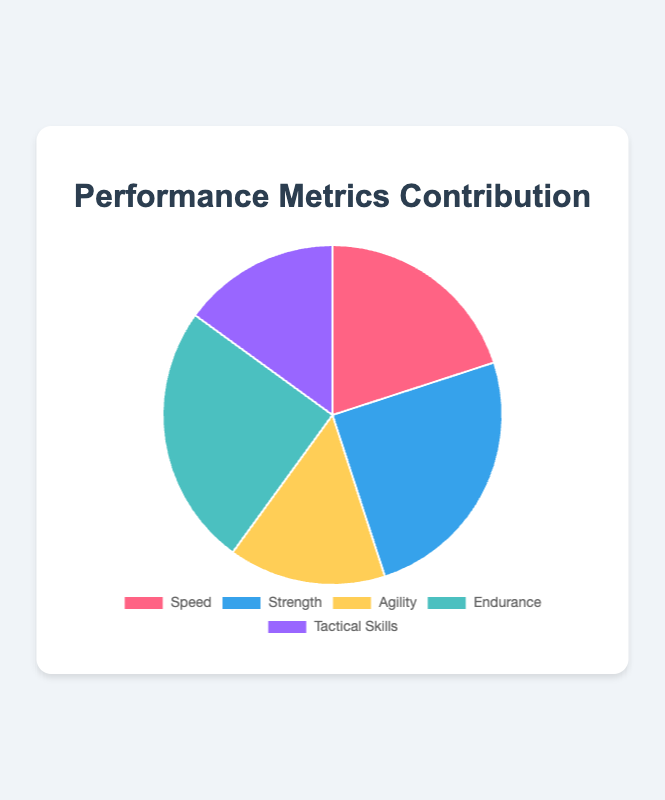What's the contribution of Speed to the overall performance metrics? The contribution of Speed is directly visible in the pie chart. It is labeled as 20%.
Answer: 20% Which two metrics both have the highest contributions? By looking at the pie chart, the segments for Strength and Endurance are the largest and are labeled with 25% each.
Answer: Strength and Endurance What is the total contribution of Agility and Tactical Skills combined? Add the contributions of Agility (15%) and Tactical Skills (15%). The total is 15% + 15% = 30%.
Answer: 30% How much more does Strength contribute compared to Speed? Subtract the contribution of Speed (20%) from the contribution of Strength (25%). The difference is 25% - 20% = 5%.
Answer: 5% Which metric has the smallest contribution, and what color represents it? Both Agility and Tactical Skills have the smallest contribution at 15%, indicated as yellow and purple segments respectively.
Answer: Agility (yellow) and Tactical Skills (purple) Is there any metric that has a contribution equal to the sum of the contributions of two other metrics? The contribution of Endurance (25%) is equal to the sum of the contributions of Agility (15%) and Tactical Skills (15% - 5% = 10%). This makes 15% + 10% = 25%.
Answer: Yes, Endurance equals Agility + Tactical Skills What percentage do Speed and Strength together contribute to the total performance? Add the contributions of Speed (20%) and Strength (25%). The combined contribution is 20% + 25% = 45%.
Answer: 45% Which metric contributes least to the performance metrics and by how much is its contribution less than the maximum? Both Agility and Tactical Skills have the least contribution at 15%. The maximum contribution is 25% of Strength or Endurance. The difference is 25% - 15% = 10%.
Answer: Agility and Tactical Skills, 10% What's the average contribution of all the metrics? Sum up all contributions (20% + 25% + 15% + 25% + 15%) which equals 100%. Divide by the number of metrics (5). The average is 100% / 5 = 20%.
Answer: 20% 